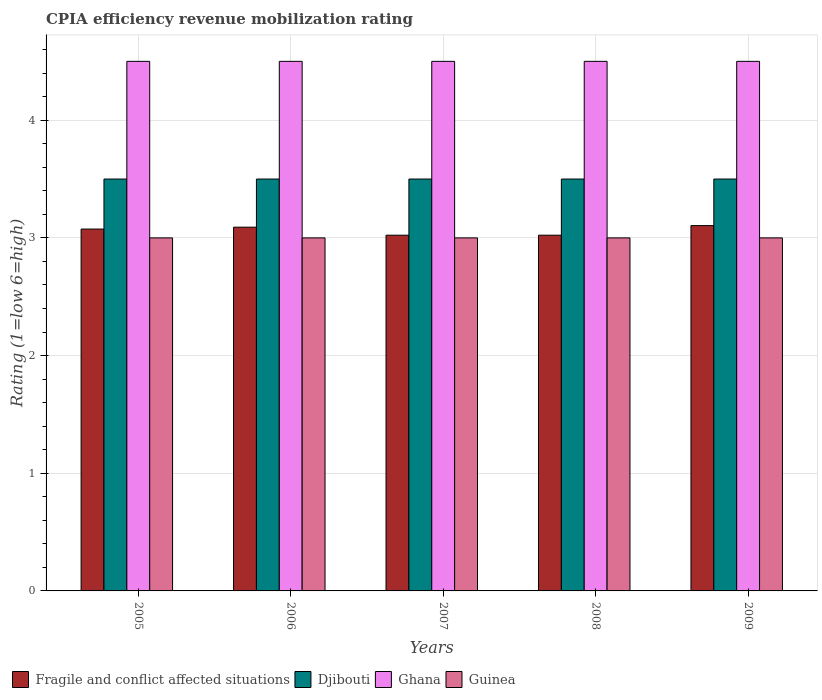Are the number of bars on each tick of the X-axis equal?
Make the answer very short. Yes. How many bars are there on the 1st tick from the left?
Your response must be concise. 4. How many bars are there on the 3rd tick from the right?
Your answer should be very brief. 4. What is the CPIA rating in Fragile and conflict affected situations in 2008?
Provide a succinct answer. 3.02. Across all years, what is the maximum CPIA rating in Djibouti?
Ensure brevity in your answer.  3.5. Across all years, what is the minimum CPIA rating in Fragile and conflict affected situations?
Keep it short and to the point. 3.02. What is the total CPIA rating in Ghana in the graph?
Offer a terse response. 22.5. What is the difference between the CPIA rating in Fragile and conflict affected situations in 2008 and that in 2009?
Keep it short and to the point. -0.08. What is the difference between the CPIA rating in Guinea in 2008 and the CPIA rating in Djibouti in 2006?
Make the answer very short. -0.5. What is the average CPIA rating in Guinea per year?
Your response must be concise. 3. In the year 2007, what is the difference between the CPIA rating in Fragile and conflict affected situations and CPIA rating in Ghana?
Make the answer very short. -1.48. Is the difference between the CPIA rating in Fragile and conflict affected situations in 2005 and 2008 greater than the difference between the CPIA rating in Ghana in 2005 and 2008?
Your response must be concise. Yes. What is the difference between the highest and the second highest CPIA rating in Fragile and conflict affected situations?
Offer a terse response. 0.01. What is the difference between the highest and the lowest CPIA rating in Fragile and conflict affected situations?
Make the answer very short. 0.08. In how many years, is the CPIA rating in Djibouti greater than the average CPIA rating in Djibouti taken over all years?
Your response must be concise. 0. Is the sum of the CPIA rating in Ghana in 2006 and 2009 greater than the maximum CPIA rating in Djibouti across all years?
Ensure brevity in your answer.  Yes. What does the 3rd bar from the left in 2005 represents?
Your answer should be very brief. Ghana. What does the 3rd bar from the right in 2006 represents?
Your answer should be compact. Djibouti. Is it the case that in every year, the sum of the CPIA rating in Djibouti and CPIA rating in Ghana is greater than the CPIA rating in Guinea?
Your answer should be compact. Yes. Are all the bars in the graph horizontal?
Your answer should be compact. No. What is the difference between two consecutive major ticks on the Y-axis?
Offer a very short reply. 1. Are the values on the major ticks of Y-axis written in scientific E-notation?
Make the answer very short. No. Does the graph contain any zero values?
Offer a terse response. No. Does the graph contain grids?
Provide a short and direct response. Yes. Where does the legend appear in the graph?
Provide a short and direct response. Bottom left. How many legend labels are there?
Your response must be concise. 4. How are the legend labels stacked?
Make the answer very short. Horizontal. What is the title of the graph?
Offer a terse response. CPIA efficiency revenue mobilization rating. What is the label or title of the X-axis?
Your answer should be compact. Years. What is the label or title of the Y-axis?
Your answer should be compact. Rating (1=low 6=high). What is the Rating (1=low 6=high) of Fragile and conflict affected situations in 2005?
Your response must be concise. 3.08. What is the Rating (1=low 6=high) of Djibouti in 2005?
Offer a terse response. 3.5. What is the Rating (1=low 6=high) of Guinea in 2005?
Keep it short and to the point. 3. What is the Rating (1=low 6=high) in Fragile and conflict affected situations in 2006?
Offer a terse response. 3.09. What is the Rating (1=low 6=high) of Ghana in 2006?
Make the answer very short. 4.5. What is the Rating (1=low 6=high) of Fragile and conflict affected situations in 2007?
Provide a short and direct response. 3.02. What is the Rating (1=low 6=high) in Ghana in 2007?
Make the answer very short. 4.5. What is the Rating (1=low 6=high) of Fragile and conflict affected situations in 2008?
Your response must be concise. 3.02. What is the Rating (1=low 6=high) of Ghana in 2008?
Provide a succinct answer. 4.5. What is the Rating (1=low 6=high) in Fragile and conflict affected situations in 2009?
Your response must be concise. 3.1. What is the Rating (1=low 6=high) in Ghana in 2009?
Give a very brief answer. 4.5. What is the Rating (1=low 6=high) in Guinea in 2009?
Offer a terse response. 3. Across all years, what is the maximum Rating (1=low 6=high) in Fragile and conflict affected situations?
Give a very brief answer. 3.1. Across all years, what is the maximum Rating (1=low 6=high) of Djibouti?
Your answer should be very brief. 3.5. Across all years, what is the minimum Rating (1=low 6=high) in Fragile and conflict affected situations?
Offer a terse response. 3.02. Across all years, what is the minimum Rating (1=low 6=high) in Ghana?
Offer a terse response. 4.5. What is the total Rating (1=low 6=high) in Fragile and conflict affected situations in the graph?
Your response must be concise. 15.32. What is the total Rating (1=low 6=high) in Ghana in the graph?
Make the answer very short. 22.5. What is the total Rating (1=low 6=high) in Guinea in the graph?
Your response must be concise. 15. What is the difference between the Rating (1=low 6=high) of Fragile and conflict affected situations in 2005 and that in 2006?
Provide a short and direct response. -0.02. What is the difference between the Rating (1=low 6=high) in Djibouti in 2005 and that in 2006?
Your response must be concise. 0. What is the difference between the Rating (1=low 6=high) in Fragile and conflict affected situations in 2005 and that in 2007?
Ensure brevity in your answer.  0.05. What is the difference between the Rating (1=low 6=high) of Djibouti in 2005 and that in 2007?
Give a very brief answer. 0. What is the difference between the Rating (1=low 6=high) in Fragile and conflict affected situations in 2005 and that in 2008?
Give a very brief answer. 0.05. What is the difference between the Rating (1=low 6=high) in Ghana in 2005 and that in 2008?
Your answer should be very brief. 0. What is the difference between the Rating (1=low 6=high) in Fragile and conflict affected situations in 2005 and that in 2009?
Give a very brief answer. -0.03. What is the difference between the Rating (1=low 6=high) of Ghana in 2005 and that in 2009?
Provide a short and direct response. 0. What is the difference between the Rating (1=low 6=high) of Guinea in 2005 and that in 2009?
Offer a very short reply. 0. What is the difference between the Rating (1=low 6=high) of Fragile and conflict affected situations in 2006 and that in 2007?
Your answer should be compact. 0.07. What is the difference between the Rating (1=low 6=high) in Djibouti in 2006 and that in 2007?
Provide a succinct answer. 0. What is the difference between the Rating (1=low 6=high) of Fragile and conflict affected situations in 2006 and that in 2008?
Provide a short and direct response. 0.07. What is the difference between the Rating (1=low 6=high) of Djibouti in 2006 and that in 2008?
Offer a very short reply. 0. What is the difference between the Rating (1=low 6=high) in Ghana in 2006 and that in 2008?
Your answer should be very brief. 0. What is the difference between the Rating (1=low 6=high) of Fragile and conflict affected situations in 2006 and that in 2009?
Your answer should be very brief. -0.01. What is the difference between the Rating (1=low 6=high) of Djibouti in 2006 and that in 2009?
Your response must be concise. 0. What is the difference between the Rating (1=low 6=high) of Ghana in 2006 and that in 2009?
Your answer should be very brief. 0. What is the difference between the Rating (1=low 6=high) of Djibouti in 2007 and that in 2008?
Give a very brief answer. 0. What is the difference between the Rating (1=low 6=high) in Ghana in 2007 and that in 2008?
Your answer should be very brief. 0. What is the difference between the Rating (1=low 6=high) of Guinea in 2007 and that in 2008?
Your answer should be compact. 0. What is the difference between the Rating (1=low 6=high) of Fragile and conflict affected situations in 2007 and that in 2009?
Provide a succinct answer. -0.08. What is the difference between the Rating (1=low 6=high) of Fragile and conflict affected situations in 2008 and that in 2009?
Give a very brief answer. -0.08. What is the difference between the Rating (1=low 6=high) in Djibouti in 2008 and that in 2009?
Provide a succinct answer. 0. What is the difference between the Rating (1=low 6=high) of Ghana in 2008 and that in 2009?
Your response must be concise. 0. What is the difference between the Rating (1=low 6=high) in Fragile and conflict affected situations in 2005 and the Rating (1=low 6=high) in Djibouti in 2006?
Your answer should be very brief. -0.42. What is the difference between the Rating (1=low 6=high) of Fragile and conflict affected situations in 2005 and the Rating (1=low 6=high) of Ghana in 2006?
Keep it short and to the point. -1.43. What is the difference between the Rating (1=low 6=high) in Fragile and conflict affected situations in 2005 and the Rating (1=low 6=high) in Guinea in 2006?
Your answer should be very brief. 0.07. What is the difference between the Rating (1=low 6=high) in Djibouti in 2005 and the Rating (1=low 6=high) in Guinea in 2006?
Your answer should be very brief. 0.5. What is the difference between the Rating (1=low 6=high) of Fragile and conflict affected situations in 2005 and the Rating (1=low 6=high) of Djibouti in 2007?
Make the answer very short. -0.42. What is the difference between the Rating (1=low 6=high) of Fragile and conflict affected situations in 2005 and the Rating (1=low 6=high) of Ghana in 2007?
Provide a short and direct response. -1.43. What is the difference between the Rating (1=low 6=high) of Fragile and conflict affected situations in 2005 and the Rating (1=low 6=high) of Guinea in 2007?
Offer a terse response. 0.07. What is the difference between the Rating (1=low 6=high) of Fragile and conflict affected situations in 2005 and the Rating (1=low 6=high) of Djibouti in 2008?
Your response must be concise. -0.42. What is the difference between the Rating (1=low 6=high) of Fragile and conflict affected situations in 2005 and the Rating (1=low 6=high) of Ghana in 2008?
Ensure brevity in your answer.  -1.43. What is the difference between the Rating (1=low 6=high) in Fragile and conflict affected situations in 2005 and the Rating (1=low 6=high) in Guinea in 2008?
Your response must be concise. 0.07. What is the difference between the Rating (1=low 6=high) in Djibouti in 2005 and the Rating (1=low 6=high) in Ghana in 2008?
Your answer should be very brief. -1. What is the difference between the Rating (1=low 6=high) of Djibouti in 2005 and the Rating (1=low 6=high) of Guinea in 2008?
Offer a terse response. 0.5. What is the difference between the Rating (1=low 6=high) of Fragile and conflict affected situations in 2005 and the Rating (1=low 6=high) of Djibouti in 2009?
Provide a succinct answer. -0.42. What is the difference between the Rating (1=low 6=high) in Fragile and conflict affected situations in 2005 and the Rating (1=low 6=high) in Ghana in 2009?
Make the answer very short. -1.43. What is the difference between the Rating (1=low 6=high) in Fragile and conflict affected situations in 2005 and the Rating (1=low 6=high) in Guinea in 2009?
Keep it short and to the point. 0.07. What is the difference between the Rating (1=low 6=high) of Djibouti in 2005 and the Rating (1=low 6=high) of Ghana in 2009?
Your answer should be compact. -1. What is the difference between the Rating (1=low 6=high) in Djibouti in 2005 and the Rating (1=low 6=high) in Guinea in 2009?
Your answer should be very brief. 0.5. What is the difference between the Rating (1=low 6=high) of Fragile and conflict affected situations in 2006 and the Rating (1=low 6=high) of Djibouti in 2007?
Provide a succinct answer. -0.41. What is the difference between the Rating (1=low 6=high) in Fragile and conflict affected situations in 2006 and the Rating (1=low 6=high) in Ghana in 2007?
Your response must be concise. -1.41. What is the difference between the Rating (1=low 6=high) of Fragile and conflict affected situations in 2006 and the Rating (1=low 6=high) of Guinea in 2007?
Ensure brevity in your answer.  0.09. What is the difference between the Rating (1=low 6=high) in Ghana in 2006 and the Rating (1=low 6=high) in Guinea in 2007?
Your response must be concise. 1.5. What is the difference between the Rating (1=low 6=high) of Fragile and conflict affected situations in 2006 and the Rating (1=low 6=high) of Djibouti in 2008?
Give a very brief answer. -0.41. What is the difference between the Rating (1=low 6=high) in Fragile and conflict affected situations in 2006 and the Rating (1=low 6=high) in Ghana in 2008?
Your answer should be very brief. -1.41. What is the difference between the Rating (1=low 6=high) in Fragile and conflict affected situations in 2006 and the Rating (1=low 6=high) in Guinea in 2008?
Your response must be concise. 0.09. What is the difference between the Rating (1=low 6=high) of Djibouti in 2006 and the Rating (1=low 6=high) of Ghana in 2008?
Make the answer very short. -1. What is the difference between the Rating (1=low 6=high) of Djibouti in 2006 and the Rating (1=low 6=high) of Guinea in 2008?
Offer a terse response. 0.5. What is the difference between the Rating (1=low 6=high) in Ghana in 2006 and the Rating (1=low 6=high) in Guinea in 2008?
Ensure brevity in your answer.  1.5. What is the difference between the Rating (1=low 6=high) of Fragile and conflict affected situations in 2006 and the Rating (1=low 6=high) of Djibouti in 2009?
Your response must be concise. -0.41. What is the difference between the Rating (1=low 6=high) in Fragile and conflict affected situations in 2006 and the Rating (1=low 6=high) in Ghana in 2009?
Provide a short and direct response. -1.41. What is the difference between the Rating (1=low 6=high) in Fragile and conflict affected situations in 2006 and the Rating (1=low 6=high) in Guinea in 2009?
Your answer should be compact. 0.09. What is the difference between the Rating (1=low 6=high) of Djibouti in 2006 and the Rating (1=low 6=high) of Guinea in 2009?
Provide a succinct answer. 0.5. What is the difference between the Rating (1=low 6=high) of Ghana in 2006 and the Rating (1=low 6=high) of Guinea in 2009?
Your response must be concise. 1.5. What is the difference between the Rating (1=low 6=high) of Fragile and conflict affected situations in 2007 and the Rating (1=low 6=high) of Djibouti in 2008?
Give a very brief answer. -0.48. What is the difference between the Rating (1=low 6=high) in Fragile and conflict affected situations in 2007 and the Rating (1=low 6=high) in Ghana in 2008?
Offer a terse response. -1.48. What is the difference between the Rating (1=low 6=high) in Fragile and conflict affected situations in 2007 and the Rating (1=low 6=high) in Guinea in 2008?
Offer a very short reply. 0.02. What is the difference between the Rating (1=low 6=high) of Djibouti in 2007 and the Rating (1=low 6=high) of Guinea in 2008?
Offer a terse response. 0.5. What is the difference between the Rating (1=low 6=high) of Ghana in 2007 and the Rating (1=low 6=high) of Guinea in 2008?
Keep it short and to the point. 1.5. What is the difference between the Rating (1=low 6=high) of Fragile and conflict affected situations in 2007 and the Rating (1=low 6=high) of Djibouti in 2009?
Provide a short and direct response. -0.48. What is the difference between the Rating (1=low 6=high) of Fragile and conflict affected situations in 2007 and the Rating (1=low 6=high) of Ghana in 2009?
Your answer should be compact. -1.48. What is the difference between the Rating (1=low 6=high) of Fragile and conflict affected situations in 2007 and the Rating (1=low 6=high) of Guinea in 2009?
Your response must be concise. 0.02. What is the difference between the Rating (1=low 6=high) in Djibouti in 2007 and the Rating (1=low 6=high) in Ghana in 2009?
Give a very brief answer. -1. What is the difference between the Rating (1=low 6=high) in Djibouti in 2007 and the Rating (1=low 6=high) in Guinea in 2009?
Your answer should be compact. 0.5. What is the difference between the Rating (1=low 6=high) in Ghana in 2007 and the Rating (1=low 6=high) in Guinea in 2009?
Give a very brief answer. 1.5. What is the difference between the Rating (1=low 6=high) in Fragile and conflict affected situations in 2008 and the Rating (1=low 6=high) in Djibouti in 2009?
Ensure brevity in your answer.  -0.48. What is the difference between the Rating (1=low 6=high) of Fragile and conflict affected situations in 2008 and the Rating (1=low 6=high) of Ghana in 2009?
Your answer should be compact. -1.48. What is the difference between the Rating (1=low 6=high) in Fragile and conflict affected situations in 2008 and the Rating (1=low 6=high) in Guinea in 2009?
Provide a succinct answer. 0.02. What is the difference between the Rating (1=low 6=high) in Djibouti in 2008 and the Rating (1=low 6=high) in Ghana in 2009?
Ensure brevity in your answer.  -1. What is the average Rating (1=low 6=high) in Fragile and conflict affected situations per year?
Provide a succinct answer. 3.06. What is the average Rating (1=low 6=high) of Djibouti per year?
Offer a very short reply. 3.5. What is the average Rating (1=low 6=high) in Guinea per year?
Your answer should be very brief. 3. In the year 2005, what is the difference between the Rating (1=low 6=high) in Fragile and conflict affected situations and Rating (1=low 6=high) in Djibouti?
Offer a very short reply. -0.42. In the year 2005, what is the difference between the Rating (1=low 6=high) of Fragile and conflict affected situations and Rating (1=low 6=high) of Ghana?
Give a very brief answer. -1.43. In the year 2005, what is the difference between the Rating (1=low 6=high) of Fragile and conflict affected situations and Rating (1=low 6=high) of Guinea?
Your answer should be very brief. 0.07. In the year 2005, what is the difference between the Rating (1=low 6=high) in Djibouti and Rating (1=low 6=high) in Ghana?
Keep it short and to the point. -1. In the year 2006, what is the difference between the Rating (1=low 6=high) of Fragile and conflict affected situations and Rating (1=low 6=high) of Djibouti?
Your answer should be compact. -0.41. In the year 2006, what is the difference between the Rating (1=low 6=high) in Fragile and conflict affected situations and Rating (1=low 6=high) in Ghana?
Keep it short and to the point. -1.41. In the year 2006, what is the difference between the Rating (1=low 6=high) of Fragile and conflict affected situations and Rating (1=low 6=high) of Guinea?
Provide a succinct answer. 0.09. In the year 2006, what is the difference between the Rating (1=low 6=high) of Djibouti and Rating (1=low 6=high) of Guinea?
Provide a succinct answer. 0.5. In the year 2007, what is the difference between the Rating (1=low 6=high) of Fragile and conflict affected situations and Rating (1=low 6=high) of Djibouti?
Provide a short and direct response. -0.48. In the year 2007, what is the difference between the Rating (1=low 6=high) in Fragile and conflict affected situations and Rating (1=low 6=high) in Ghana?
Offer a very short reply. -1.48. In the year 2007, what is the difference between the Rating (1=low 6=high) in Fragile and conflict affected situations and Rating (1=low 6=high) in Guinea?
Make the answer very short. 0.02. In the year 2007, what is the difference between the Rating (1=low 6=high) in Djibouti and Rating (1=low 6=high) in Ghana?
Ensure brevity in your answer.  -1. In the year 2007, what is the difference between the Rating (1=low 6=high) of Djibouti and Rating (1=low 6=high) of Guinea?
Provide a succinct answer. 0.5. In the year 2008, what is the difference between the Rating (1=low 6=high) of Fragile and conflict affected situations and Rating (1=low 6=high) of Djibouti?
Your answer should be very brief. -0.48. In the year 2008, what is the difference between the Rating (1=low 6=high) of Fragile and conflict affected situations and Rating (1=low 6=high) of Ghana?
Make the answer very short. -1.48. In the year 2008, what is the difference between the Rating (1=low 6=high) in Fragile and conflict affected situations and Rating (1=low 6=high) in Guinea?
Provide a succinct answer. 0.02. In the year 2008, what is the difference between the Rating (1=low 6=high) of Djibouti and Rating (1=low 6=high) of Guinea?
Offer a terse response. 0.5. In the year 2009, what is the difference between the Rating (1=low 6=high) in Fragile and conflict affected situations and Rating (1=low 6=high) in Djibouti?
Give a very brief answer. -0.4. In the year 2009, what is the difference between the Rating (1=low 6=high) of Fragile and conflict affected situations and Rating (1=low 6=high) of Ghana?
Give a very brief answer. -1.4. In the year 2009, what is the difference between the Rating (1=low 6=high) of Fragile and conflict affected situations and Rating (1=low 6=high) of Guinea?
Make the answer very short. 0.1. In the year 2009, what is the difference between the Rating (1=low 6=high) in Djibouti and Rating (1=low 6=high) in Guinea?
Make the answer very short. 0.5. What is the ratio of the Rating (1=low 6=high) of Djibouti in 2005 to that in 2006?
Give a very brief answer. 1. What is the ratio of the Rating (1=low 6=high) of Fragile and conflict affected situations in 2005 to that in 2007?
Provide a short and direct response. 1.02. What is the ratio of the Rating (1=low 6=high) of Ghana in 2005 to that in 2007?
Give a very brief answer. 1. What is the ratio of the Rating (1=low 6=high) of Guinea in 2005 to that in 2007?
Ensure brevity in your answer.  1. What is the ratio of the Rating (1=low 6=high) of Fragile and conflict affected situations in 2005 to that in 2008?
Keep it short and to the point. 1.02. What is the ratio of the Rating (1=low 6=high) in Ghana in 2005 to that in 2008?
Keep it short and to the point. 1. What is the ratio of the Rating (1=low 6=high) in Guinea in 2005 to that in 2008?
Offer a terse response. 1. What is the ratio of the Rating (1=low 6=high) in Fragile and conflict affected situations in 2005 to that in 2009?
Your answer should be very brief. 0.99. What is the ratio of the Rating (1=low 6=high) in Djibouti in 2005 to that in 2009?
Ensure brevity in your answer.  1. What is the ratio of the Rating (1=low 6=high) of Fragile and conflict affected situations in 2006 to that in 2007?
Make the answer very short. 1.02. What is the ratio of the Rating (1=low 6=high) of Ghana in 2006 to that in 2007?
Ensure brevity in your answer.  1. What is the ratio of the Rating (1=low 6=high) of Fragile and conflict affected situations in 2006 to that in 2008?
Give a very brief answer. 1.02. What is the ratio of the Rating (1=low 6=high) in Ghana in 2006 to that in 2008?
Ensure brevity in your answer.  1. What is the ratio of the Rating (1=low 6=high) of Guinea in 2006 to that in 2008?
Provide a short and direct response. 1. What is the ratio of the Rating (1=low 6=high) of Fragile and conflict affected situations in 2006 to that in 2009?
Make the answer very short. 1. What is the ratio of the Rating (1=low 6=high) in Djibouti in 2006 to that in 2009?
Give a very brief answer. 1. What is the ratio of the Rating (1=low 6=high) in Ghana in 2006 to that in 2009?
Offer a very short reply. 1. What is the ratio of the Rating (1=low 6=high) of Djibouti in 2007 to that in 2008?
Ensure brevity in your answer.  1. What is the ratio of the Rating (1=low 6=high) in Ghana in 2007 to that in 2008?
Offer a terse response. 1. What is the ratio of the Rating (1=low 6=high) in Guinea in 2007 to that in 2008?
Offer a terse response. 1. What is the ratio of the Rating (1=low 6=high) in Fragile and conflict affected situations in 2007 to that in 2009?
Your response must be concise. 0.97. What is the ratio of the Rating (1=low 6=high) in Fragile and conflict affected situations in 2008 to that in 2009?
Offer a very short reply. 0.97. What is the ratio of the Rating (1=low 6=high) of Djibouti in 2008 to that in 2009?
Your response must be concise. 1. What is the ratio of the Rating (1=low 6=high) in Ghana in 2008 to that in 2009?
Make the answer very short. 1. What is the ratio of the Rating (1=low 6=high) in Guinea in 2008 to that in 2009?
Provide a succinct answer. 1. What is the difference between the highest and the second highest Rating (1=low 6=high) of Fragile and conflict affected situations?
Keep it short and to the point. 0.01. What is the difference between the highest and the second highest Rating (1=low 6=high) in Guinea?
Offer a very short reply. 0. What is the difference between the highest and the lowest Rating (1=low 6=high) in Fragile and conflict affected situations?
Keep it short and to the point. 0.08. 